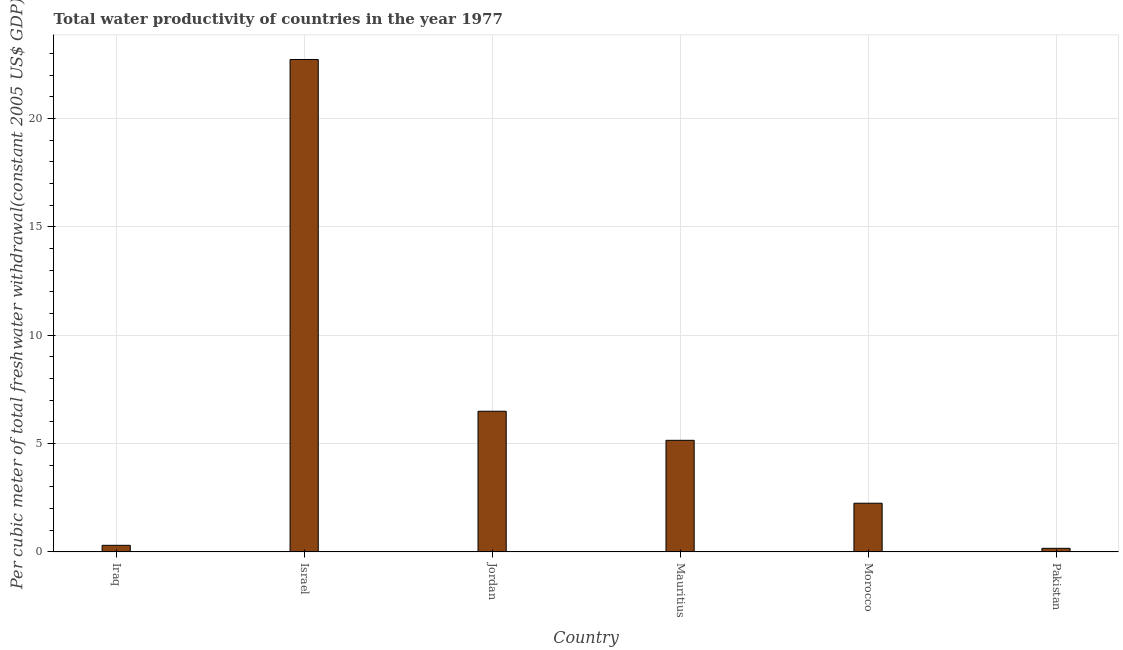Does the graph contain grids?
Your response must be concise. Yes. What is the title of the graph?
Your response must be concise. Total water productivity of countries in the year 1977. What is the label or title of the X-axis?
Your answer should be compact. Country. What is the label or title of the Y-axis?
Keep it short and to the point. Per cubic meter of total freshwater withdrawal(constant 2005 US$ GDP). What is the total water productivity in Pakistan?
Provide a short and direct response. 0.17. Across all countries, what is the maximum total water productivity?
Provide a succinct answer. 22.72. Across all countries, what is the minimum total water productivity?
Your answer should be very brief. 0.17. In which country was the total water productivity maximum?
Offer a very short reply. Israel. In which country was the total water productivity minimum?
Your response must be concise. Pakistan. What is the sum of the total water productivity?
Provide a short and direct response. 37.09. What is the difference between the total water productivity in Mauritius and Morocco?
Offer a very short reply. 2.9. What is the average total water productivity per country?
Keep it short and to the point. 6.18. What is the median total water productivity?
Provide a short and direct response. 3.7. What is the ratio of the total water productivity in Israel to that in Mauritius?
Your response must be concise. 4.41. Is the difference between the total water productivity in Israel and Pakistan greater than the difference between any two countries?
Your answer should be very brief. Yes. What is the difference between the highest and the second highest total water productivity?
Provide a succinct answer. 16.23. Is the sum of the total water productivity in Iraq and Jordan greater than the maximum total water productivity across all countries?
Ensure brevity in your answer.  No. What is the difference between the highest and the lowest total water productivity?
Ensure brevity in your answer.  22.56. In how many countries, is the total water productivity greater than the average total water productivity taken over all countries?
Your answer should be compact. 2. How many bars are there?
Ensure brevity in your answer.  6. How many countries are there in the graph?
Keep it short and to the point. 6. What is the difference between two consecutive major ticks on the Y-axis?
Your response must be concise. 5. What is the Per cubic meter of total freshwater withdrawal(constant 2005 US$ GDP) in Iraq?
Give a very brief answer. 0.31. What is the Per cubic meter of total freshwater withdrawal(constant 2005 US$ GDP) of Israel?
Provide a succinct answer. 22.72. What is the Per cubic meter of total freshwater withdrawal(constant 2005 US$ GDP) of Jordan?
Provide a short and direct response. 6.49. What is the Per cubic meter of total freshwater withdrawal(constant 2005 US$ GDP) in Mauritius?
Offer a very short reply. 5.15. What is the Per cubic meter of total freshwater withdrawal(constant 2005 US$ GDP) of Morocco?
Keep it short and to the point. 2.25. What is the Per cubic meter of total freshwater withdrawal(constant 2005 US$ GDP) of Pakistan?
Provide a short and direct response. 0.17. What is the difference between the Per cubic meter of total freshwater withdrawal(constant 2005 US$ GDP) in Iraq and Israel?
Your response must be concise. -22.42. What is the difference between the Per cubic meter of total freshwater withdrawal(constant 2005 US$ GDP) in Iraq and Jordan?
Offer a very short reply. -6.19. What is the difference between the Per cubic meter of total freshwater withdrawal(constant 2005 US$ GDP) in Iraq and Mauritius?
Make the answer very short. -4.84. What is the difference between the Per cubic meter of total freshwater withdrawal(constant 2005 US$ GDP) in Iraq and Morocco?
Give a very brief answer. -1.94. What is the difference between the Per cubic meter of total freshwater withdrawal(constant 2005 US$ GDP) in Iraq and Pakistan?
Keep it short and to the point. 0.14. What is the difference between the Per cubic meter of total freshwater withdrawal(constant 2005 US$ GDP) in Israel and Jordan?
Offer a terse response. 16.23. What is the difference between the Per cubic meter of total freshwater withdrawal(constant 2005 US$ GDP) in Israel and Mauritius?
Offer a very short reply. 17.57. What is the difference between the Per cubic meter of total freshwater withdrawal(constant 2005 US$ GDP) in Israel and Morocco?
Keep it short and to the point. 20.48. What is the difference between the Per cubic meter of total freshwater withdrawal(constant 2005 US$ GDP) in Israel and Pakistan?
Your answer should be compact. 22.56. What is the difference between the Per cubic meter of total freshwater withdrawal(constant 2005 US$ GDP) in Jordan and Mauritius?
Your answer should be compact. 1.34. What is the difference between the Per cubic meter of total freshwater withdrawal(constant 2005 US$ GDP) in Jordan and Morocco?
Keep it short and to the point. 4.24. What is the difference between the Per cubic meter of total freshwater withdrawal(constant 2005 US$ GDP) in Jordan and Pakistan?
Keep it short and to the point. 6.32. What is the difference between the Per cubic meter of total freshwater withdrawal(constant 2005 US$ GDP) in Mauritius and Morocco?
Ensure brevity in your answer.  2.9. What is the difference between the Per cubic meter of total freshwater withdrawal(constant 2005 US$ GDP) in Mauritius and Pakistan?
Offer a terse response. 4.98. What is the difference between the Per cubic meter of total freshwater withdrawal(constant 2005 US$ GDP) in Morocco and Pakistan?
Your answer should be compact. 2.08. What is the ratio of the Per cubic meter of total freshwater withdrawal(constant 2005 US$ GDP) in Iraq to that in Israel?
Provide a succinct answer. 0.01. What is the ratio of the Per cubic meter of total freshwater withdrawal(constant 2005 US$ GDP) in Iraq to that in Jordan?
Provide a short and direct response. 0.05. What is the ratio of the Per cubic meter of total freshwater withdrawal(constant 2005 US$ GDP) in Iraq to that in Mauritius?
Your response must be concise. 0.06. What is the ratio of the Per cubic meter of total freshwater withdrawal(constant 2005 US$ GDP) in Iraq to that in Morocco?
Keep it short and to the point. 0.14. What is the ratio of the Per cubic meter of total freshwater withdrawal(constant 2005 US$ GDP) in Iraq to that in Pakistan?
Offer a very short reply. 1.83. What is the ratio of the Per cubic meter of total freshwater withdrawal(constant 2005 US$ GDP) in Israel to that in Jordan?
Your answer should be very brief. 3.5. What is the ratio of the Per cubic meter of total freshwater withdrawal(constant 2005 US$ GDP) in Israel to that in Mauritius?
Your response must be concise. 4.41. What is the ratio of the Per cubic meter of total freshwater withdrawal(constant 2005 US$ GDP) in Israel to that in Morocco?
Your answer should be very brief. 10.11. What is the ratio of the Per cubic meter of total freshwater withdrawal(constant 2005 US$ GDP) in Israel to that in Pakistan?
Provide a short and direct response. 135.84. What is the ratio of the Per cubic meter of total freshwater withdrawal(constant 2005 US$ GDP) in Jordan to that in Mauritius?
Your answer should be very brief. 1.26. What is the ratio of the Per cubic meter of total freshwater withdrawal(constant 2005 US$ GDP) in Jordan to that in Morocco?
Provide a short and direct response. 2.89. What is the ratio of the Per cubic meter of total freshwater withdrawal(constant 2005 US$ GDP) in Jordan to that in Pakistan?
Your response must be concise. 38.81. What is the ratio of the Per cubic meter of total freshwater withdrawal(constant 2005 US$ GDP) in Mauritius to that in Morocco?
Your response must be concise. 2.29. What is the ratio of the Per cubic meter of total freshwater withdrawal(constant 2005 US$ GDP) in Mauritius to that in Pakistan?
Provide a short and direct response. 30.79. What is the ratio of the Per cubic meter of total freshwater withdrawal(constant 2005 US$ GDP) in Morocco to that in Pakistan?
Keep it short and to the point. 13.44. 